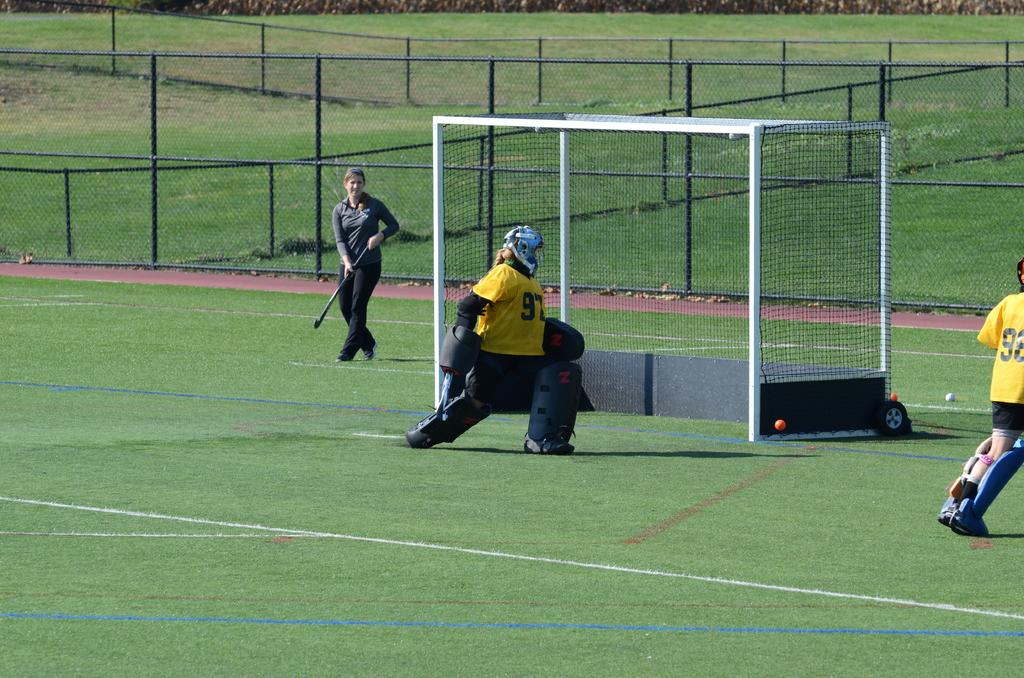<image>
Share a concise interpretation of the image provided. A goalie wearing number 97 protects the goal. 